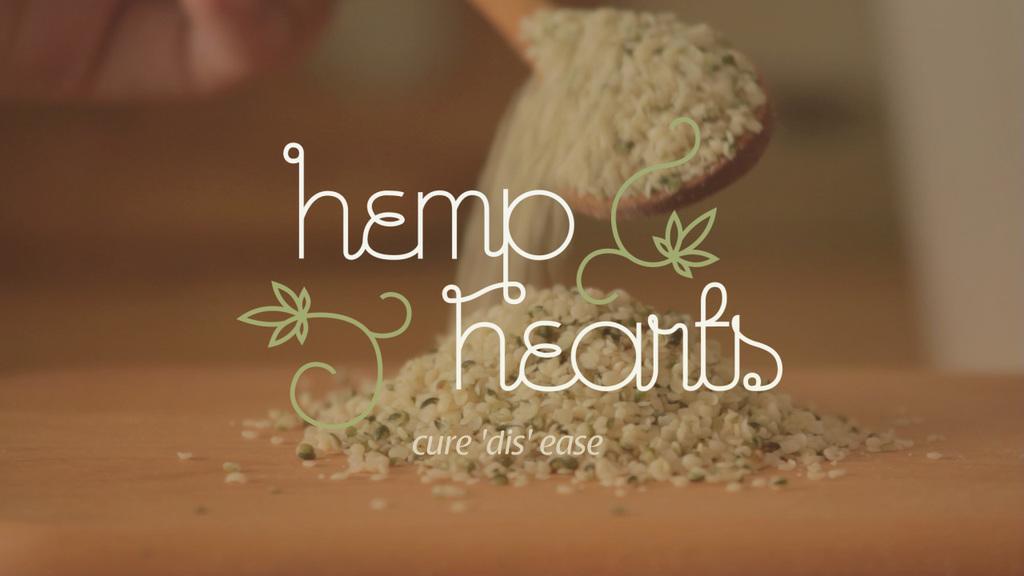In one or two sentences, can you explain what this image depicts? In this image there is a spoon of grains falling on the board, and there are watermarks on the image. 